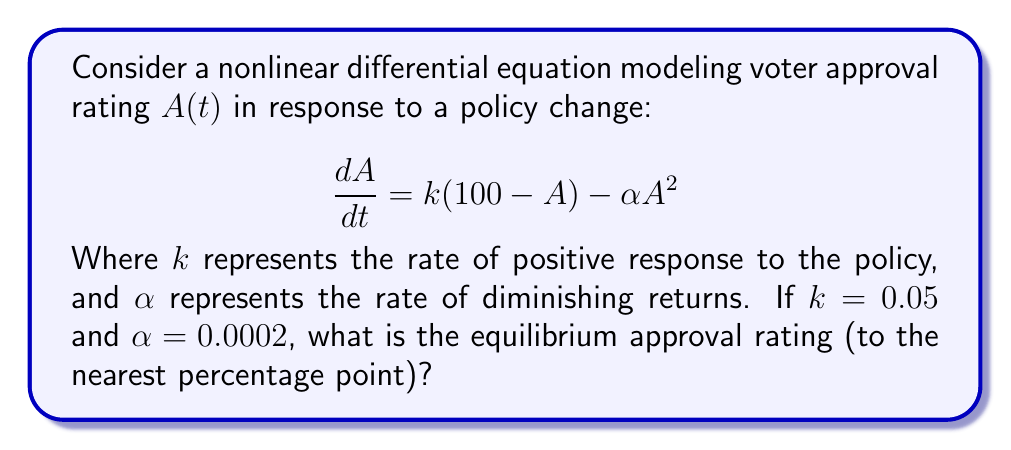Can you answer this question? To find the equilibrium approval rating, we need to solve for $A$ when $\frac{dA}{dt} = 0$:

1) Set the equation equal to zero:
   $$0 = k(100-A) - \alpha A^2$$

2) Substitute the given values:
   $$0 = 0.05(100-A) - 0.0002A^2$$

3) Expand the equation:
   $$0 = 5 - 0.05A - 0.0002A^2$$

4) Rearrange to standard quadratic form:
   $$0.0002A^2 + 0.05A - 5 = 0$$

5) Use the quadratic formula $A = \frac{-b \pm \sqrt{b^2 - 4ac}}{2a}$:
   $$A = \frac{-0.05 \pm \sqrt{0.05^2 - 4(0.0002)(-5)}}{2(0.0002)}$$

6) Simplify:
   $$A = \frac{-0.05 \pm \sqrt{0.0025 + 0.004}}{0.0004}$$
   $$A = \frac{-0.05 \pm \sqrt{0.0065}}{0.0004}$$
   $$A = \frac{-0.05 \pm 0.0806}{0.0004}$$

7) This gives us two solutions:
   $$A_1 = \frac{-0.05 + 0.0806}{0.0004} = 76.5$$
   $$A_2 = \frac{-0.05 - 0.0806}{0.0004} = -326.5$$

8) Since approval rating cannot be negative, we discard the second solution.

9) Rounding to the nearest percentage point:
   $$A \approx 77\%$$
Answer: 77% 